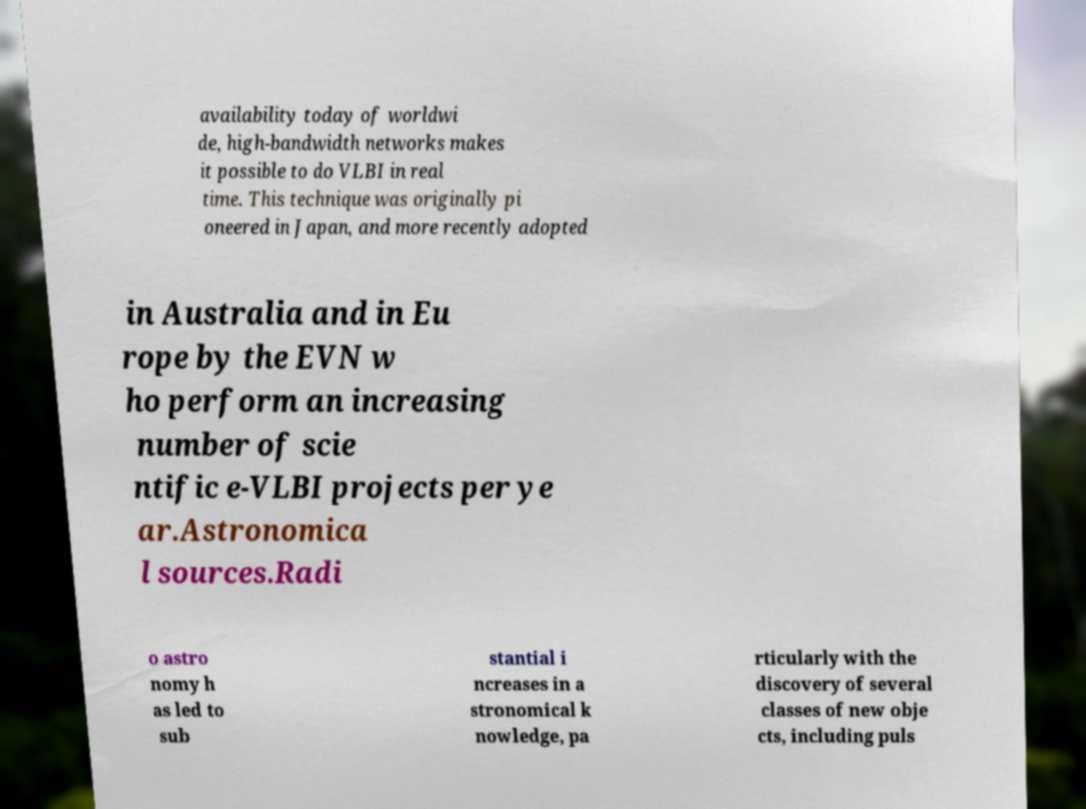Can you read and provide the text displayed in the image?This photo seems to have some interesting text. Can you extract and type it out for me? availability today of worldwi de, high-bandwidth networks makes it possible to do VLBI in real time. This technique was originally pi oneered in Japan, and more recently adopted in Australia and in Eu rope by the EVN w ho perform an increasing number of scie ntific e-VLBI projects per ye ar.Astronomica l sources.Radi o astro nomy h as led to sub stantial i ncreases in a stronomical k nowledge, pa rticularly with the discovery of several classes of new obje cts, including puls 